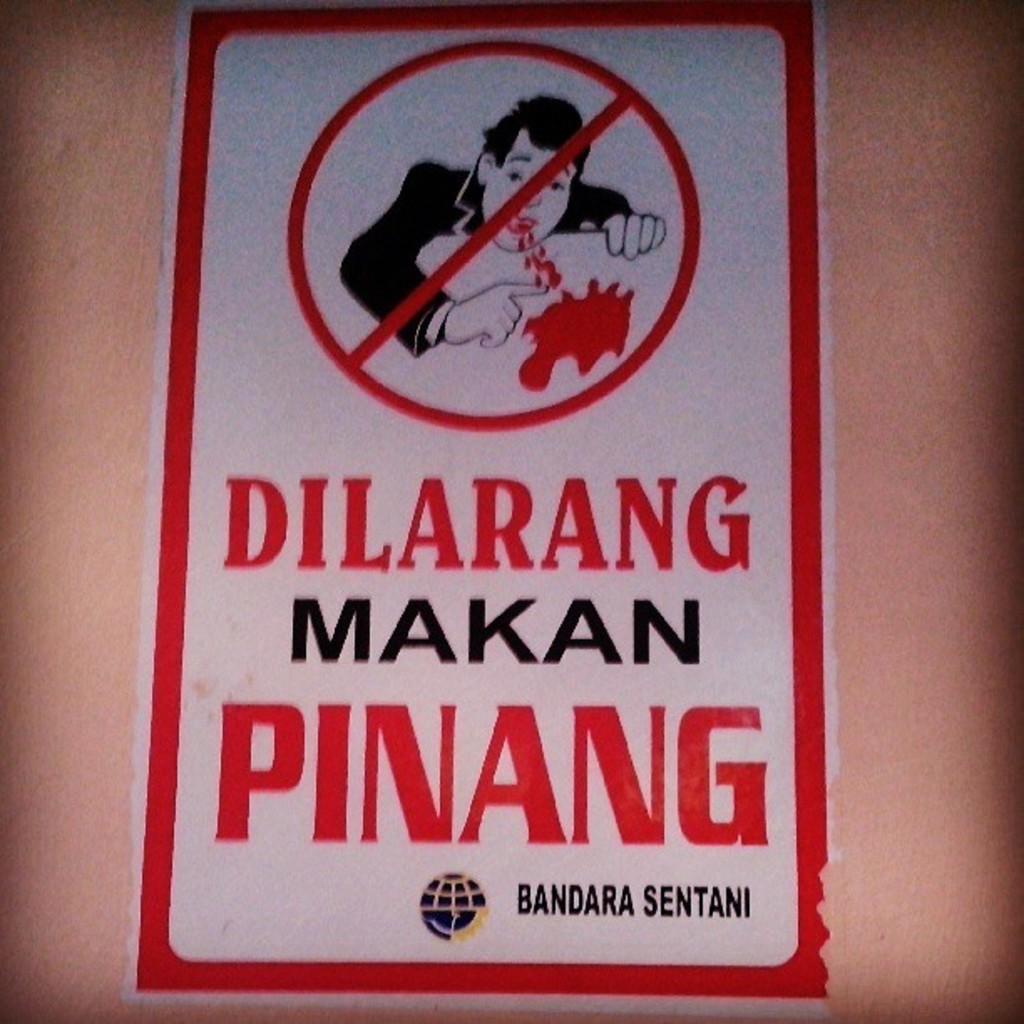What does the sign say?
Provide a succinct answer. Dilarang makan pinang. What is the first word on the sign?
Your answer should be very brief. Dilarang. 